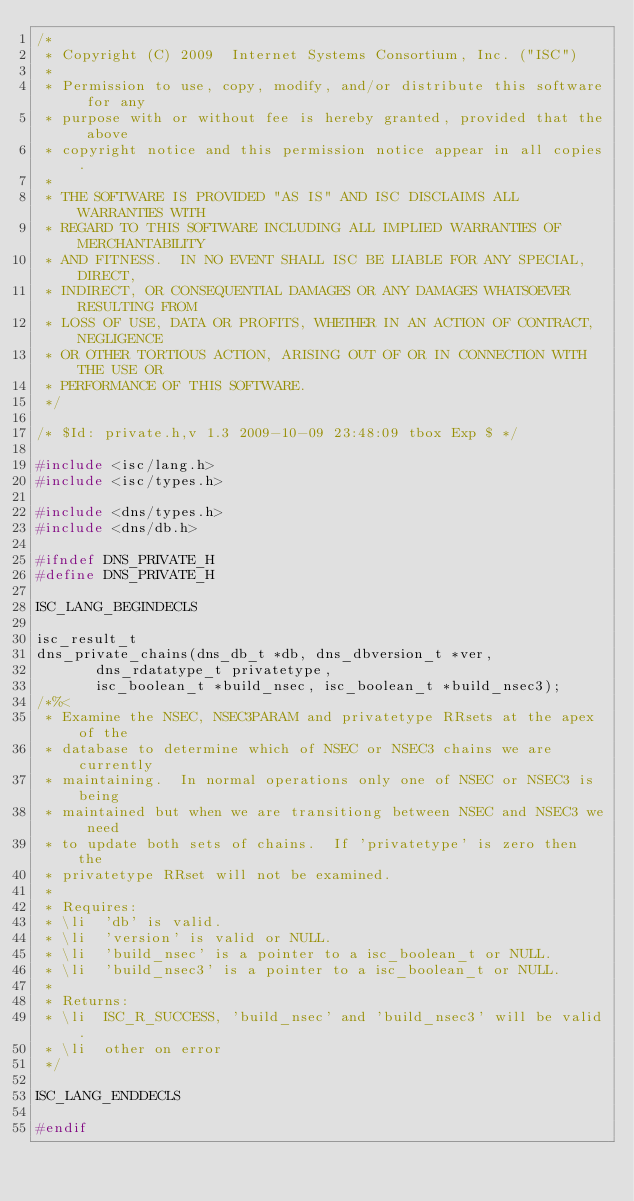<code> <loc_0><loc_0><loc_500><loc_500><_C_>/*
 * Copyright (C) 2009  Internet Systems Consortium, Inc. ("ISC")
 *
 * Permission to use, copy, modify, and/or distribute this software for any
 * purpose with or without fee is hereby granted, provided that the above
 * copyright notice and this permission notice appear in all copies.
 *
 * THE SOFTWARE IS PROVIDED "AS IS" AND ISC DISCLAIMS ALL WARRANTIES WITH
 * REGARD TO THIS SOFTWARE INCLUDING ALL IMPLIED WARRANTIES OF MERCHANTABILITY
 * AND FITNESS.  IN NO EVENT SHALL ISC BE LIABLE FOR ANY SPECIAL, DIRECT,
 * INDIRECT, OR CONSEQUENTIAL DAMAGES OR ANY DAMAGES WHATSOEVER RESULTING FROM
 * LOSS OF USE, DATA OR PROFITS, WHETHER IN AN ACTION OF CONTRACT, NEGLIGENCE
 * OR OTHER TORTIOUS ACTION, ARISING OUT OF OR IN CONNECTION WITH THE USE OR
 * PERFORMANCE OF THIS SOFTWARE.
 */

/* $Id: private.h,v 1.3 2009-10-09 23:48:09 tbox Exp $ */

#include <isc/lang.h>
#include <isc/types.h>

#include <dns/types.h>
#include <dns/db.h>

#ifndef DNS_PRIVATE_H
#define DNS_PRIVATE_H

ISC_LANG_BEGINDECLS

isc_result_t
dns_private_chains(dns_db_t *db, dns_dbversion_t *ver,
		   dns_rdatatype_t privatetype,
		   isc_boolean_t *build_nsec, isc_boolean_t *build_nsec3);
/*%<
 * Examine the NSEC, NSEC3PARAM and privatetype RRsets at the apex of the
 * database to determine which of NSEC or NSEC3 chains we are currently
 * maintaining.  In normal operations only one of NSEC or NSEC3 is being
 * maintained but when we are transitiong between NSEC and NSEC3 we need
 * to update both sets of chains.  If 'privatetype' is zero then the
 * privatetype RRset will not be examined.
 *
 * Requires:
 * \li	'db' is valid.
 * \li	'version' is valid or NULL.
 * \li	'build_nsec' is a pointer to a isc_boolean_t or NULL.
 * \li	'build_nsec3' is a pointer to a isc_boolean_t or NULL.
 *
 * Returns:
 * \li 	ISC_R_SUCCESS, 'build_nsec' and 'build_nsec3' will be valid.
 * \li	other on error
 */

ISC_LANG_ENDDECLS

#endif
</code> 